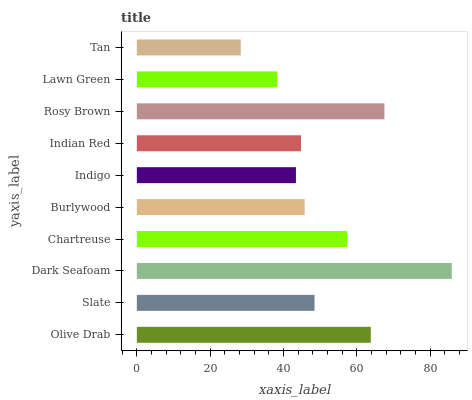Is Tan the minimum?
Answer yes or no. Yes. Is Dark Seafoam the maximum?
Answer yes or no. Yes. Is Slate the minimum?
Answer yes or no. No. Is Slate the maximum?
Answer yes or no. No. Is Olive Drab greater than Slate?
Answer yes or no. Yes. Is Slate less than Olive Drab?
Answer yes or no. Yes. Is Slate greater than Olive Drab?
Answer yes or no. No. Is Olive Drab less than Slate?
Answer yes or no. No. Is Slate the high median?
Answer yes or no. Yes. Is Burlywood the low median?
Answer yes or no. Yes. Is Olive Drab the high median?
Answer yes or no. No. Is Rosy Brown the low median?
Answer yes or no. No. 